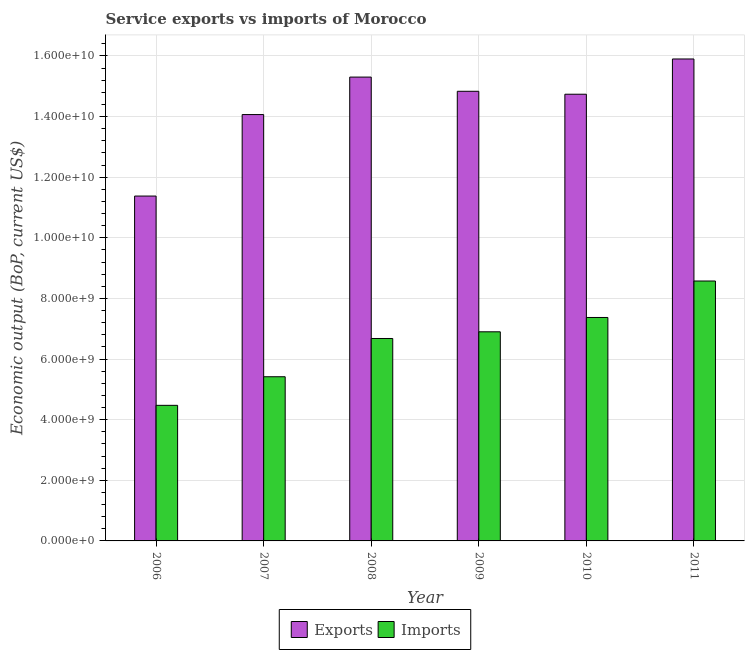Are the number of bars per tick equal to the number of legend labels?
Provide a short and direct response. Yes. What is the label of the 6th group of bars from the left?
Your answer should be compact. 2011. What is the amount of service exports in 2007?
Offer a very short reply. 1.41e+1. Across all years, what is the maximum amount of service exports?
Ensure brevity in your answer.  1.59e+1. Across all years, what is the minimum amount of service imports?
Your response must be concise. 4.47e+09. What is the total amount of service exports in the graph?
Give a very brief answer. 8.62e+1. What is the difference between the amount of service exports in 2006 and that in 2011?
Offer a terse response. -4.52e+09. What is the difference between the amount of service imports in 2011 and the amount of service exports in 2006?
Provide a short and direct response. 4.10e+09. What is the average amount of service exports per year?
Your response must be concise. 1.44e+1. What is the ratio of the amount of service imports in 2009 to that in 2010?
Make the answer very short. 0.94. Is the amount of service exports in 2006 less than that in 2007?
Keep it short and to the point. Yes. What is the difference between the highest and the second highest amount of service exports?
Your response must be concise. 5.97e+08. What is the difference between the highest and the lowest amount of service exports?
Keep it short and to the point. 4.52e+09. In how many years, is the amount of service exports greater than the average amount of service exports taken over all years?
Your answer should be compact. 4. Is the sum of the amount of service exports in 2008 and 2010 greater than the maximum amount of service imports across all years?
Your response must be concise. Yes. What does the 2nd bar from the left in 2008 represents?
Offer a very short reply. Imports. What does the 2nd bar from the right in 2011 represents?
Offer a very short reply. Exports. How many bars are there?
Offer a very short reply. 12. Are the values on the major ticks of Y-axis written in scientific E-notation?
Give a very brief answer. Yes. Does the graph contain any zero values?
Make the answer very short. No. Does the graph contain grids?
Make the answer very short. Yes. Where does the legend appear in the graph?
Make the answer very short. Bottom center. How many legend labels are there?
Provide a short and direct response. 2. What is the title of the graph?
Keep it short and to the point. Service exports vs imports of Morocco. What is the label or title of the X-axis?
Offer a very short reply. Year. What is the label or title of the Y-axis?
Offer a terse response. Economic output (BoP, current US$). What is the Economic output (BoP, current US$) of Exports in 2006?
Offer a very short reply. 1.14e+1. What is the Economic output (BoP, current US$) in Imports in 2006?
Offer a very short reply. 4.47e+09. What is the Economic output (BoP, current US$) in Exports in 2007?
Your response must be concise. 1.41e+1. What is the Economic output (BoP, current US$) in Imports in 2007?
Give a very brief answer. 5.42e+09. What is the Economic output (BoP, current US$) of Exports in 2008?
Provide a short and direct response. 1.53e+1. What is the Economic output (BoP, current US$) in Imports in 2008?
Your answer should be compact. 6.68e+09. What is the Economic output (BoP, current US$) of Exports in 2009?
Provide a succinct answer. 1.48e+1. What is the Economic output (BoP, current US$) of Imports in 2009?
Keep it short and to the point. 6.90e+09. What is the Economic output (BoP, current US$) of Exports in 2010?
Offer a very short reply. 1.47e+1. What is the Economic output (BoP, current US$) in Imports in 2010?
Your answer should be very brief. 7.37e+09. What is the Economic output (BoP, current US$) of Exports in 2011?
Offer a very short reply. 1.59e+1. What is the Economic output (BoP, current US$) of Imports in 2011?
Provide a short and direct response. 8.57e+09. Across all years, what is the maximum Economic output (BoP, current US$) of Exports?
Your response must be concise. 1.59e+1. Across all years, what is the maximum Economic output (BoP, current US$) of Imports?
Make the answer very short. 8.57e+09. Across all years, what is the minimum Economic output (BoP, current US$) in Exports?
Offer a very short reply. 1.14e+1. Across all years, what is the minimum Economic output (BoP, current US$) of Imports?
Keep it short and to the point. 4.47e+09. What is the total Economic output (BoP, current US$) of Exports in the graph?
Provide a succinct answer. 8.62e+1. What is the total Economic output (BoP, current US$) of Imports in the graph?
Your response must be concise. 3.94e+1. What is the difference between the Economic output (BoP, current US$) in Exports in 2006 and that in 2007?
Your response must be concise. -2.69e+09. What is the difference between the Economic output (BoP, current US$) in Imports in 2006 and that in 2007?
Give a very brief answer. -9.43e+08. What is the difference between the Economic output (BoP, current US$) of Exports in 2006 and that in 2008?
Your answer should be compact. -3.92e+09. What is the difference between the Economic output (BoP, current US$) in Imports in 2006 and that in 2008?
Offer a very short reply. -2.21e+09. What is the difference between the Economic output (BoP, current US$) of Exports in 2006 and that in 2009?
Your response must be concise. -3.46e+09. What is the difference between the Economic output (BoP, current US$) of Imports in 2006 and that in 2009?
Give a very brief answer. -2.43e+09. What is the difference between the Economic output (BoP, current US$) of Exports in 2006 and that in 2010?
Offer a terse response. -3.36e+09. What is the difference between the Economic output (BoP, current US$) in Imports in 2006 and that in 2010?
Provide a succinct answer. -2.90e+09. What is the difference between the Economic output (BoP, current US$) in Exports in 2006 and that in 2011?
Your answer should be very brief. -4.52e+09. What is the difference between the Economic output (BoP, current US$) of Imports in 2006 and that in 2011?
Ensure brevity in your answer.  -4.10e+09. What is the difference between the Economic output (BoP, current US$) in Exports in 2007 and that in 2008?
Ensure brevity in your answer.  -1.24e+09. What is the difference between the Economic output (BoP, current US$) of Imports in 2007 and that in 2008?
Your answer should be very brief. -1.26e+09. What is the difference between the Economic output (BoP, current US$) in Exports in 2007 and that in 2009?
Your answer should be compact. -7.68e+08. What is the difference between the Economic output (BoP, current US$) in Imports in 2007 and that in 2009?
Offer a terse response. -1.48e+09. What is the difference between the Economic output (BoP, current US$) of Exports in 2007 and that in 2010?
Keep it short and to the point. -6.71e+08. What is the difference between the Economic output (BoP, current US$) in Imports in 2007 and that in 2010?
Provide a succinct answer. -1.96e+09. What is the difference between the Economic output (BoP, current US$) of Exports in 2007 and that in 2011?
Make the answer very short. -1.83e+09. What is the difference between the Economic output (BoP, current US$) of Imports in 2007 and that in 2011?
Offer a terse response. -3.16e+09. What is the difference between the Economic output (BoP, current US$) in Exports in 2008 and that in 2009?
Your answer should be compact. 4.69e+08. What is the difference between the Economic output (BoP, current US$) of Imports in 2008 and that in 2009?
Give a very brief answer. -2.20e+08. What is the difference between the Economic output (BoP, current US$) of Exports in 2008 and that in 2010?
Keep it short and to the point. 5.66e+08. What is the difference between the Economic output (BoP, current US$) of Imports in 2008 and that in 2010?
Offer a very short reply. -6.93e+08. What is the difference between the Economic output (BoP, current US$) in Exports in 2008 and that in 2011?
Your answer should be compact. -5.97e+08. What is the difference between the Economic output (BoP, current US$) of Imports in 2008 and that in 2011?
Ensure brevity in your answer.  -1.90e+09. What is the difference between the Economic output (BoP, current US$) in Exports in 2009 and that in 2010?
Give a very brief answer. 9.66e+07. What is the difference between the Economic output (BoP, current US$) of Imports in 2009 and that in 2010?
Offer a terse response. -4.73e+08. What is the difference between the Economic output (BoP, current US$) in Exports in 2009 and that in 2011?
Provide a succinct answer. -1.07e+09. What is the difference between the Economic output (BoP, current US$) of Imports in 2009 and that in 2011?
Ensure brevity in your answer.  -1.68e+09. What is the difference between the Economic output (BoP, current US$) in Exports in 2010 and that in 2011?
Ensure brevity in your answer.  -1.16e+09. What is the difference between the Economic output (BoP, current US$) in Imports in 2010 and that in 2011?
Your response must be concise. -1.20e+09. What is the difference between the Economic output (BoP, current US$) in Exports in 2006 and the Economic output (BoP, current US$) in Imports in 2007?
Offer a very short reply. 5.96e+09. What is the difference between the Economic output (BoP, current US$) in Exports in 2006 and the Economic output (BoP, current US$) in Imports in 2008?
Your answer should be very brief. 4.70e+09. What is the difference between the Economic output (BoP, current US$) in Exports in 2006 and the Economic output (BoP, current US$) in Imports in 2009?
Your answer should be compact. 4.48e+09. What is the difference between the Economic output (BoP, current US$) of Exports in 2006 and the Economic output (BoP, current US$) of Imports in 2010?
Keep it short and to the point. 4.01e+09. What is the difference between the Economic output (BoP, current US$) of Exports in 2006 and the Economic output (BoP, current US$) of Imports in 2011?
Keep it short and to the point. 2.80e+09. What is the difference between the Economic output (BoP, current US$) in Exports in 2007 and the Economic output (BoP, current US$) in Imports in 2008?
Provide a succinct answer. 7.39e+09. What is the difference between the Economic output (BoP, current US$) of Exports in 2007 and the Economic output (BoP, current US$) of Imports in 2009?
Keep it short and to the point. 7.17e+09. What is the difference between the Economic output (BoP, current US$) in Exports in 2007 and the Economic output (BoP, current US$) in Imports in 2010?
Your response must be concise. 6.69e+09. What is the difference between the Economic output (BoP, current US$) of Exports in 2007 and the Economic output (BoP, current US$) of Imports in 2011?
Offer a very short reply. 5.49e+09. What is the difference between the Economic output (BoP, current US$) of Exports in 2008 and the Economic output (BoP, current US$) of Imports in 2009?
Your answer should be very brief. 8.40e+09. What is the difference between the Economic output (BoP, current US$) of Exports in 2008 and the Economic output (BoP, current US$) of Imports in 2010?
Your answer should be compact. 7.93e+09. What is the difference between the Economic output (BoP, current US$) in Exports in 2008 and the Economic output (BoP, current US$) in Imports in 2011?
Offer a terse response. 6.73e+09. What is the difference between the Economic output (BoP, current US$) in Exports in 2009 and the Economic output (BoP, current US$) in Imports in 2010?
Keep it short and to the point. 7.46e+09. What is the difference between the Economic output (BoP, current US$) of Exports in 2009 and the Economic output (BoP, current US$) of Imports in 2011?
Your answer should be very brief. 6.26e+09. What is the difference between the Economic output (BoP, current US$) in Exports in 2010 and the Economic output (BoP, current US$) in Imports in 2011?
Provide a succinct answer. 6.16e+09. What is the average Economic output (BoP, current US$) of Exports per year?
Your answer should be compact. 1.44e+1. What is the average Economic output (BoP, current US$) in Imports per year?
Provide a succinct answer. 6.57e+09. In the year 2006, what is the difference between the Economic output (BoP, current US$) of Exports and Economic output (BoP, current US$) of Imports?
Your answer should be compact. 6.90e+09. In the year 2007, what is the difference between the Economic output (BoP, current US$) in Exports and Economic output (BoP, current US$) in Imports?
Make the answer very short. 8.65e+09. In the year 2008, what is the difference between the Economic output (BoP, current US$) in Exports and Economic output (BoP, current US$) in Imports?
Give a very brief answer. 8.62e+09. In the year 2009, what is the difference between the Economic output (BoP, current US$) of Exports and Economic output (BoP, current US$) of Imports?
Provide a short and direct response. 7.93e+09. In the year 2010, what is the difference between the Economic output (BoP, current US$) in Exports and Economic output (BoP, current US$) in Imports?
Give a very brief answer. 7.36e+09. In the year 2011, what is the difference between the Economic output (BoP, current US$) in Exports and Economic output (BoP, current US$) in Imports?
Offer a very short reply. 7.32e+09. What is the ratio of the Economic output (BoP, current US$) of Exports in 2006 to that in 2007?
Ensure brevity in your answer.  0.81. What is the ratio of the Economic output (BoP, current US$) of Imports in 2006 to that in 2007?
Ensure brevity in your answer.  0.83. What is the ratio of the Economic output (BoP, current US$) of Exports in 2006 to that in 2008?
Make the answer very short. 0.74. What is the ratio of the Economic output (BoP, current US$) in Imports in 2006 to that in 2008?
Your response must be concise. 0.67. What is the ratio of the Economic output (BoP, current US$) of Exports in 2006 to that in 2009?
Give a very brief answer. 0.77. What is the ratio of the Economic output (BoP, current US$) of Imports in 2006 to that in 2009?
Offer a terse response. 0.65. What is the ratio of the Economic output (BoP, current US$) of Exports in 2006 to that in 2010?
Ensure brevity in your answer.  0.77. What is the ratio of the Economic output (BoP, current US$) in Imports in 2006 to that in 2010?
Your response must be concise. 0.61. What is the ratio of the Economic output (BoP, current US$) of Exports in 2006 to that in 2011?
Ensure brevity in your answer.  0.72. What is the ratio of the Economic output (BoP, current US$) of Imports in 2006 to that in 2011?
Your response must be concise. 0.52. What is the ratio of the Economic output (BoP, current US$) in Exports in 2007 to that in 2008?
Your response must be concise. 0.92. What is the ratio of the Economic output (BoP, current US$) of Imports in 2007 to that in 2008?
Provide a short and direct response. 0.81. What is the ratio of the Economic output (BoP, current US$) in Exports in 2007 to that in 2009?
Give a very brief answer. 0.95. What is the ratio of the Economic output (BoP, current US$) of Imports in 2007 to that in 2009?
Give a very brief answer. 0.79. What is the ratio of the Economic output (BoP, current US$) of Exports in 2007 to that in 2010?
Your answer should be compact. 0.95. What is the ratio of the Economic output (BoP, current US$) of Imports in 2007 to that in 2010?
Provide a short and direct response. 0.73. What is the ratio of the Economic output (BoP, current US$) of Exports in 2007 to that in 2011?
Your answer should be very brief. 0.88. What is the ratio of the Economic output (BoP, current US$) of Imports in 2007 to that in 2011?
Your response must be concise. 0.63. What is the ratio of the Economic output (BoP, current US$) of Exports in 2008 to that in 2009?
Give a very brief answer. 1.03. What is the ratio of the Economic output (BoP, current US$) in Imports in 2008 to that in 2009?
Your response must be concise. 0.97. What is the ratio of the Economic output (BoP, current US$) of Exports in 2008 to that in 2010?
Your answer should be very brief. 1.04. What is the ratio of the Economic output (BoP, current US$) in Imports in 2008 to that in 2010?
Ensure brevity in your answer.  0.91. What is the ratio of the Economic output (BoP, current US$) in Exports in 2008 to that in 2011?
Provide a succinct answer. 0.96. What is the ratio of the Economic output (BoP, current US$) of Imports in 2008 to that in 2011?
Make the answer very short. 0.78. What is the ratio of the Economic output (BoP, current US$) in Exports in 2009 to that in 2010?
Provide a succinct answer. 1.01. What is the ratio of the Economic output (BoP, current US$) of Imports in 2009 to that in 2010?
Provide a short and direct response. 0.94. What is the ratio of the Economic output (BoP, current US$) of Exports in 2009 to that in 2011?
Offer a terse response. 0.93. What is the ratio of the Economic output (BoP, current US$) in Imports in 2009 to that in 2011?
Keep it short and to the point. 0.8. What is the ratio of the Economic output (BoP, current US$) of Exports in 2010 to that in 2011?
Offer a very short reply. 0.93. What is the ratio of the Economic output (BoP, current US$) of Imports in 2010 to that in 2011?
Offer a terse response. 0.86. What is the difference between the highest and the second highest Economic output (BoP, current US$) of Exports?
Provide a short and direct response. 5.97e+08. What is the difference between the highest and the second highest Economic output (BoP, current US$) in Imports?
Offer a very short reply. 1.20e+09. What is the difference between the highest and the lowest Economic output (BoP, current US$) of Exports?
Give a very brief answer. 4.52e+09. What is the difference between the highest and the lowest Economic output (BoP, current US$) in Imports?
Offer a very short reply. 4.10e+09. 